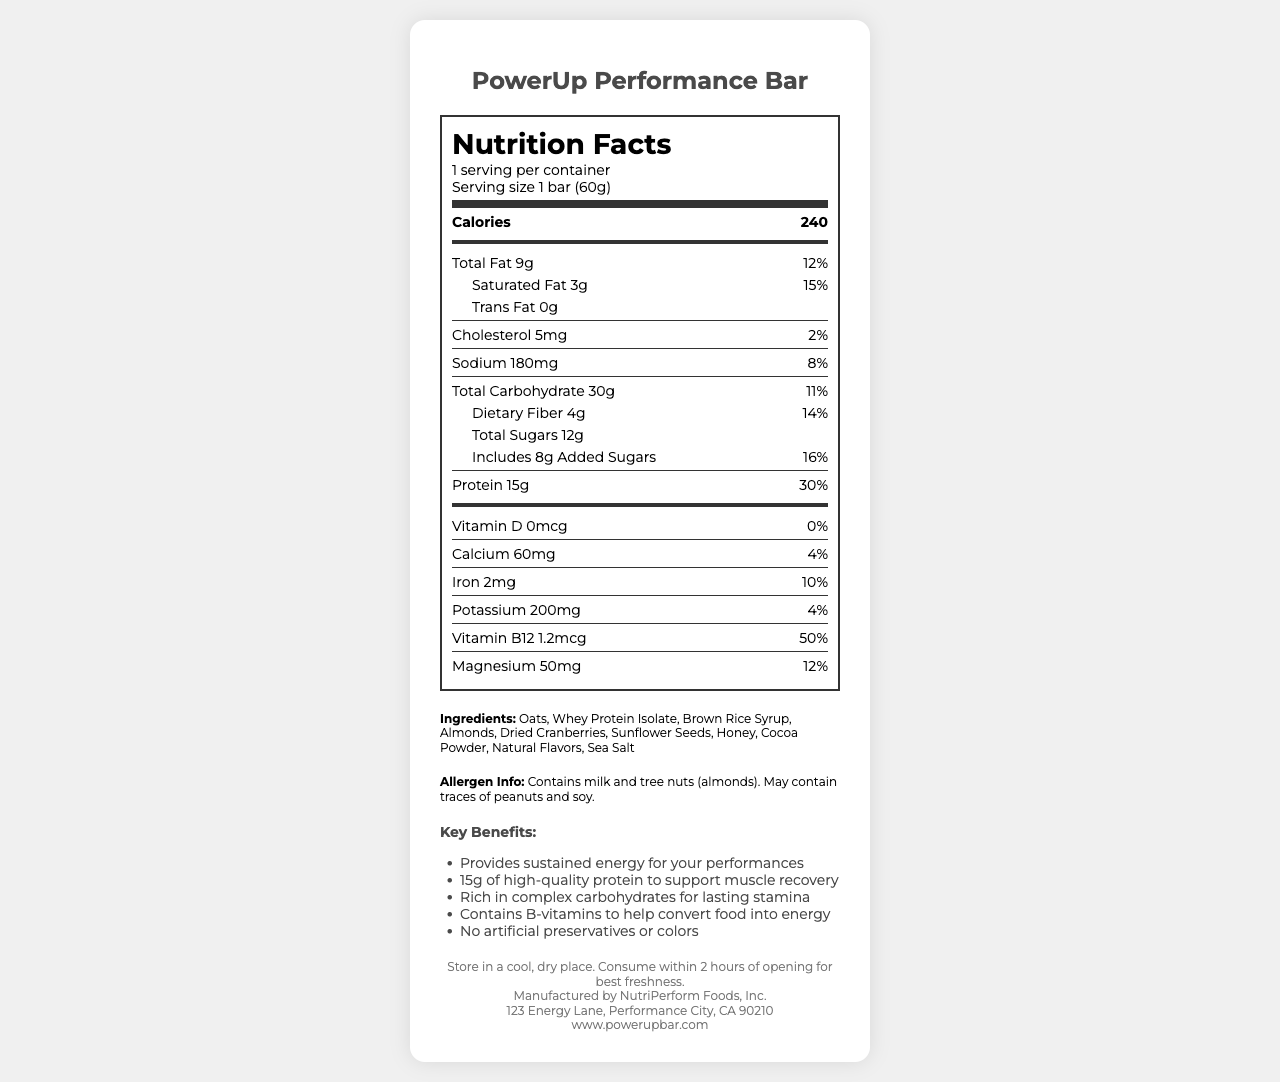What is the serving size for the PowerUp Performance Bar? The serving size is clearly listed at the top of the nutrition label as "1 bar (60g)."
Answer: 1 bar (60g) How many calories are in one serving of the PowerUp Performance Bar? The calories are displayed prominently in the nutrition facts label as "Calories 240."
Answer: 240 How much protein does the bar contain? The protein content is listed as "15g" in the nutrition facts section.
Answer: 15g What is the daily value percentage for added sugars in this bar? The daily value percentage for added sugars is listed as "16%" in the nutrition facts section.
Answer: 16% What are the first three ingredients listed on the PowerUp Performance Bar? The ingredients are listed toward the bottom of the document, and the first three are "Oats, Whey Protein Isolate, Brown Rice Syrup."
Answer: Oats, Whey Protein Isolate, Brown Rice Syrup Which of the following nutrients is NOT present in the PowerUp Performance Bar? A. Vitamin D B. Calcium C. Iron D. Potassium The amount of Vitamin D is listed as "0mcg," indicating it is not present in the bar. Calcium, Iron, and Potassium all have values listed.
Answer: A. Vitamin D What is the total amount of dietary fiber in the PowerUp Performance Bar? A. 3g B. 4g C. 5g D. 8g The total dietary fiber is listed as "4g" in the nutrition facts section.
Answer: B. 4g How many servings per container are there? A. 1 B. 2 C. 3 D. 4 The document states there are "1 serving per container."
Answer: A. 1 Does the PowerUp Performance Bar contain any trans fat? The amount of trans fat is listed as "0g" in the nutrition facts section, indicating that it contains no trans fat.
Answer: No What are the key marketing claims of the PowerUp Performance Bar? These claims are listed under the "Key Benefits" section in bullet points.
Answer: Provides sustained energy for your performances, 15g of high-quality protein to support muscle recovery, Rich in complex carbohydrates for lasting stamina, Contains B-vitamins to help convert food into energy, No artificial preservatives or colors What is the main idea of the document? The document includes an extensive nutrition facts section, a detailed ingredient list, allergen information, and several marketing claims highlighting the product's benefits.
Answer: The document provides detailed nutritional information and benefits of the PowerUp Performance Bar, designed to offer pre-performance energy and support muscle recovery. Where is the manufacturer of the PowerUp Performance Bar located? The address of the manufacturer is provided at the bottom of the document.
Answer: 123 Energy Lane, Performance City, CA 90210 What is the daily value percentage for saturated fat in the PowerUp Performance Bar? The daily value percentage for saturated fat is listed as "15%" in the nutrition facts section.
Answer: 15% How much sodium does the bar contain? The sodium content is listed as "180mg" in the nutrition facts section.
Answer: 180mg What are the specific allergies mentioned in the allergen information? The allergen information clearly states "Contains milk and tree nuts (almonds). May contain traces of peanuts and soy."
Answer: Contains milk and tree nuts (almonds). May contain traces of peanuts and soy. Can the PowerUp Performance Bar be refrigerated? The document only states, "Store in a cool, dry place," but does not mention refrigeration.
Answer: Not enough information 